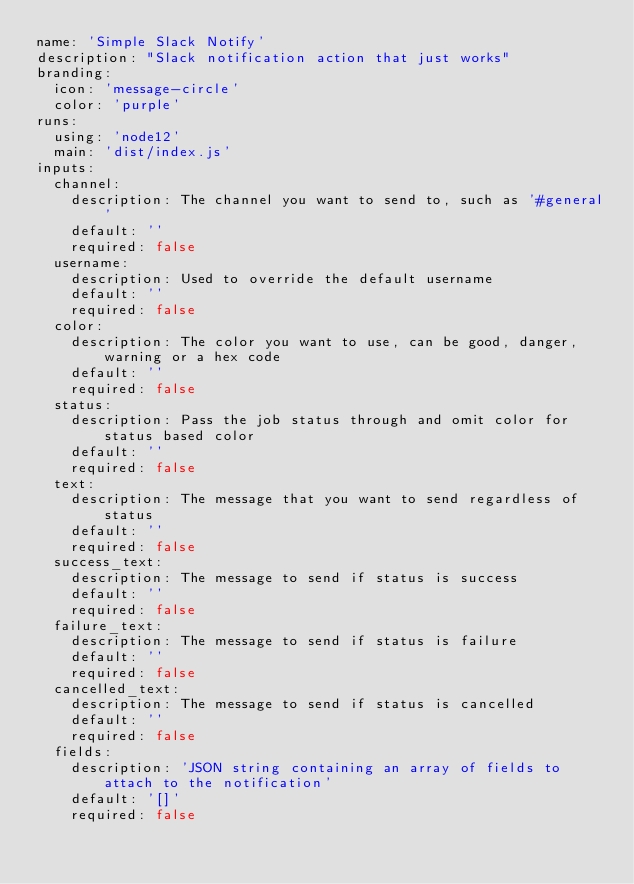<code> <loc_0><loc_0><loc_500><loc_500><_YAML_>name: 'Simple Slack Notify'
description: "Slack notification action that just works"
branding:
  icon: 'message-circle'
  color: 'purple'
runs:
  using: 'node12'
  main: 'dist/index.js'
inputs:
  channel:
    description: The channel you want to send to, such as '#general'
    default: ''
    required: false
  username:
    description: Used to override the default username
    default: ''
    required: false
  color:
    description: The color you want to use, can be good, danger, warning or a hex code
    default: ''
    required: false
  status:
    description: Pass the job status through and omit color for status based color
    default: ''
    required: false
  text:
    description: The message that you want to send regardless of status
    default: ''
    required: false
  success_text:
    description: The message to send if status is success
    default: ''
    required: false
  failure_text:
    description: The message to send if status is failure
    default: ''
    required: false
  cancelled_text:
    description: The message to send if status is cancelled
    default: ''
    required: false
  fields:
    description: 'JSON string containing an array of fields to attach to the notification'
    default: '[]'
    required: false
</code> 